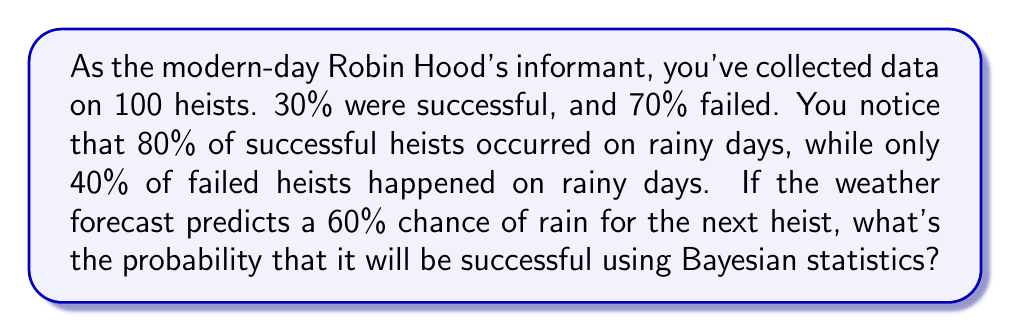Could you help me with this problem? Let's solve this using Bayesian statistics:

1) Define our events:
   S: Successful heist
   R: Rainy day

2) Given information:
   P(S) = 0.30 (prior probability of success)
   P(R|S) = 0.80 (probability of rain given success)
   P(R|not S) = 0.40 (probability of rain given failure)
   P(R) = 0.60 (probability of rain for next heist)

3) We want to find P(S|R) using Bayes' theorem:

   $$P(S|R) = \frac{P(R|S) \cdot P(S)}{P(R)}$$

4) We need to calculate P(R) using the law of total probability:

   $$P(R) = P(R|S) \cdot P(S) + P(R|not S) \cdot P(not S)$$
   $$P(R) = 0.80 \cdot 0.30 + 0.40 \cdot 0.70 = 0.24 + 0.28 = 0.52$$

5) Now we can apply Bayes' theorem:

   $$P(S|R) = \frac{0.80 \cdot 0.30}{0.60} = \frac{0.24}{0.60} = 0.40$$

Therefore, given a 60% chance of rain, the probability of a successful heist is 40%.
Answer: 0.40 or 40% 